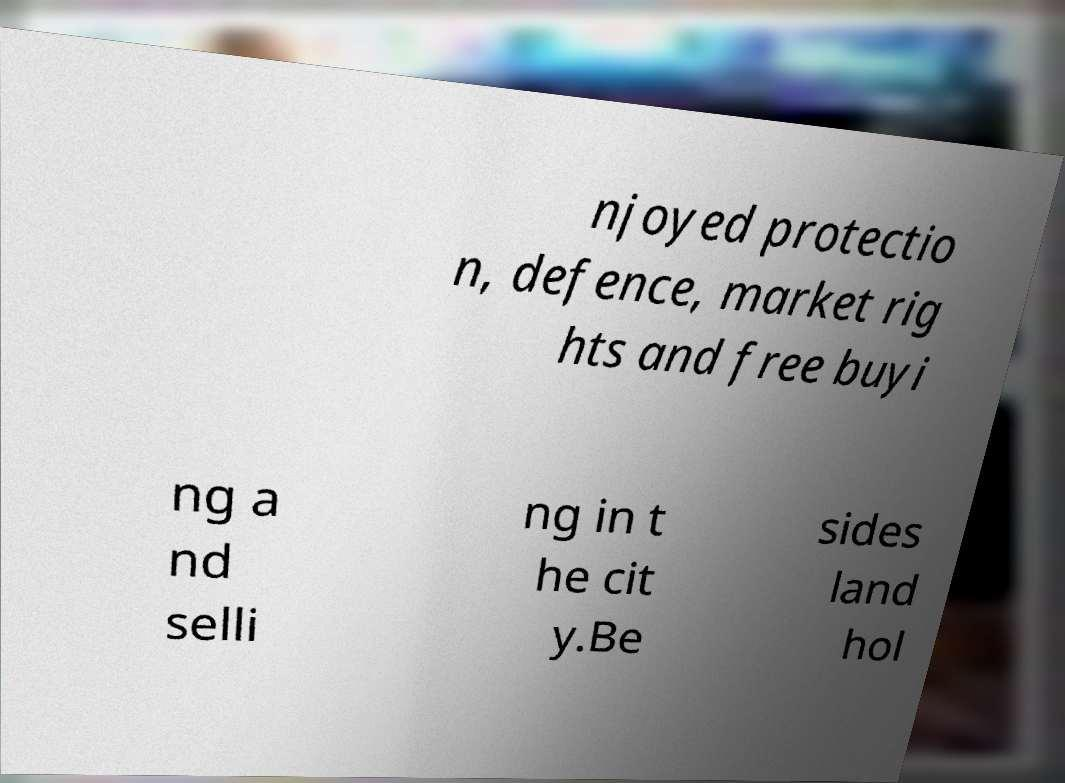There's text embedded in this image that I need extracted. Can you transcribe it verbatim? njoyed protectio n, defence, market rig hts and free buyi ng a nd selli ng in t he cit y.Be sides land hol 